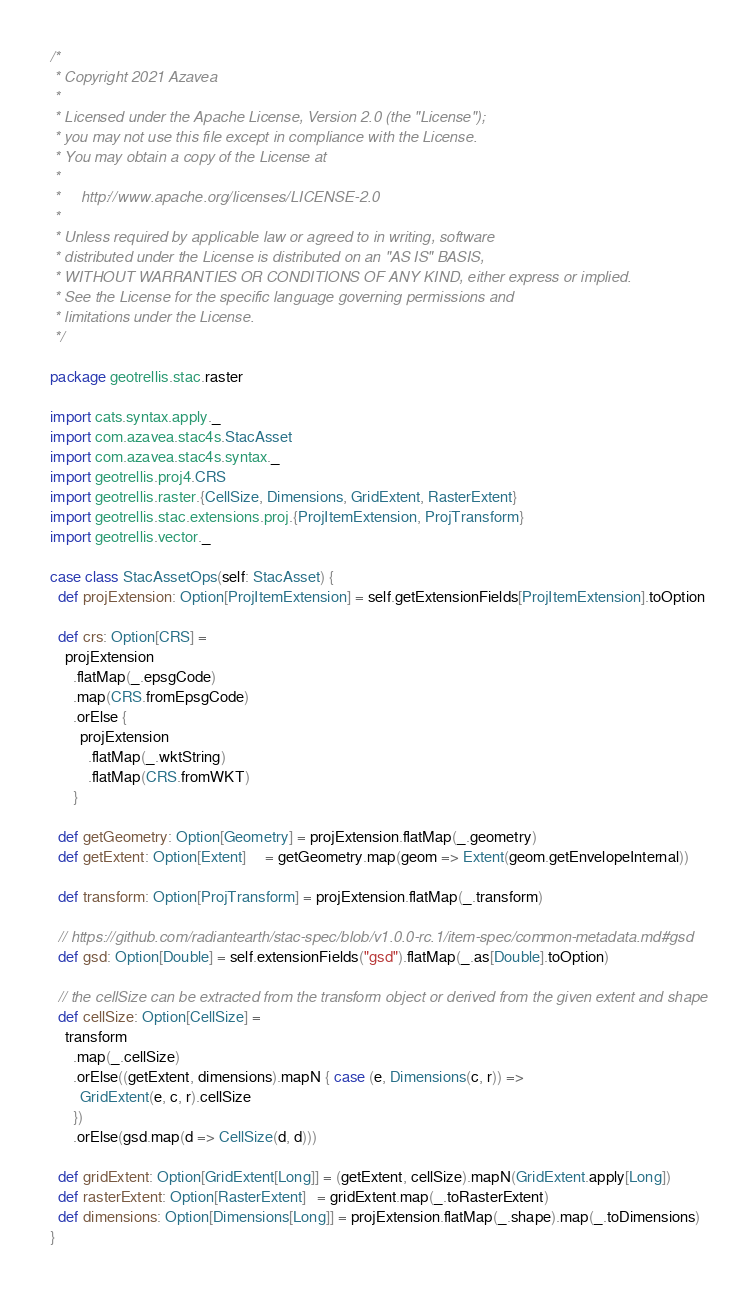<code> <loc_0><loc_0><loc_500><loc_500><_Scala_>/*
 * Copyright 2021 Azavea
 *
 * Licensed under the Apache License, Version 2.0 (the "License");
 * you may not use this file except in compliance with the License.
 * You may obtain a copy of the License at
 *
 *     http://www.apache.org/licenses/LICENSE-2.0
 *
 * Unless required by applicable law or agreed to in writing, software
 * distributed under the License is distributed on an "AS IS" BASIS,
 * WITHOUT WARRANTIES OR CONDITIONS OF ANY KIND, either express or implied.
 * See the License for the specific language governing permissions and
 * limitations under the License.
 */

package geotrellis.stac.raster

import cats.syntax.apply._
import com.azavea.stac4s.StacAsset
import com.azavea.stac4s.syntax._
import geotrellis.proj4.CRS
import geotrellis.raster.{CellSize, Dimensions, GridExtent, RasterExtent}
import geotrellis.stac.extensions.proj.{ProjItemExtension, ProjTransform}
import geotrellis.vector._

case class StacAssetOps(self: StacAsset) {
  def projExtension: Option[ProjItemExtension] = self.getExtensionFields[ProjItemExtension].toOption

  def crs: Option[CRS] =
    projExtension
      .flatMap(_.epsgCode)
      .map(CRS.fromEpsgCode)
      .orElse {
        projExtension
          .flatMap(_.wktString)
          .flatMap(CRS.fromWKT)
      }

  def getGeometry: Option[Geometry] = projExtension.flatMap(_.geometry)
  def getExtent: Option[Extent]     = getGeometry.map(geom => Extent(geom.getEnvelopeInternal))

  def transform: Option[ProjTransform] = projExtension.flatMap(_.transform)

  // https://github.com/radiantearth/stac-spec/blob/v1.0.0-rc.1/item-spec/common-metadata.md#gsd
  def gsd: Option[Double] = self.extensionFields("gsd").flatMap(_.as[Double].toOption)

  // the cellSize can be extracted from the transform object or derived from the given extent and shape
  def cellSize: Option[CellSize] =
    transform
      .map(_.cellSize)
      .orElse((getExtent, dimensions).mapN { case (e, Dimensions(c, r)) =>
        GridExtent(e, c, r).cellSize
      })
      .orElse(gsd.map(d => CellSize(d, d)))

  def gridExtent: Option[GridExtent[Long]] = (getExtent, cellSize).mapN(GridExtent.apply[Long])
  def rasterExtent: Option[RasterExtent]   = gridExtent.map(_.toRasterExtent)
  def dimensions: Option[Dimensions[Long]] = projExtension.flatMap(_.shape).map(_.toDimensions)
}
</code> 